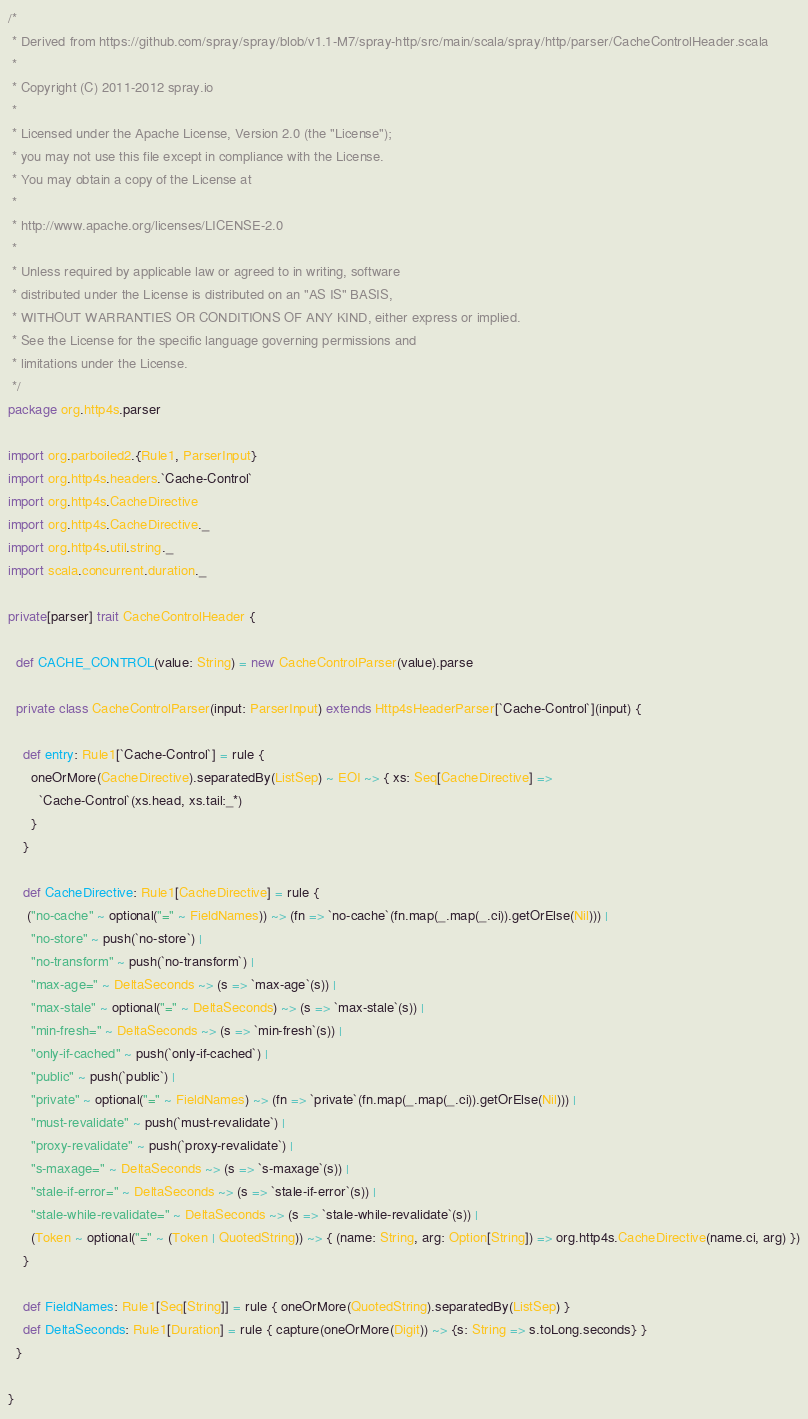<code> <loc_0><loc_0><loc_500><loc_500><_Scala_>/*
 * Derived from https://github.com/spray/spray/blob/v1.1-M7/spray-http/src/main/scala/spray/http/parser/CacheControlHeader.scala
 *
 * Copyright (C) 2011-2012 spray.io
 *
 * Licensed under the Apache License, Version 2.0 (the "License");
 * you may not use this file except in compliance with the License.
 * You may obtain a copy of the License at
 *
 * http://www.apache.org/licenses/LICENSE-2.0
 *
 * Unless required by applicable law or agreed to in writing, software
 * distributed under the License is distributed on an "AS IS" BASIS,
 * WITHOUT WARRANTIES OR CONDITIONS OF ANY KIND, either express or implied.
 * See the License for the specific language governing permissions and
 * limitations under the License.
 */
package org.http4s.parser

import org.parboiled2.{Rule1, ParserInput}
import org.http4s.headers.`Cache-Control`
import org.http4s.CacheDirective
import org.http4s.CacheDirective._
import org.http4s.util.string._
import scala.concurrent.duration._

private[parser] trait CacheControlHeader {

  def CACHE_CONTROL(value: String) = new CacheControlParser(value).parse

  private class CacheControlParser(input: ParserInput) extends Http4sHeaderParser[`Cache-Control`](input) {

    def entry: Rule1[`Cache-Control`] = rule {
      oneOrMore(CacheDirective).separatedBy(ListSep) ~ EOI ~> { xs: Seq[CacheDirective] =>
        `Cache-Control`(xs.head, xs.tail:_*)
      }
    }

    def CacheDirective: Rule1[CacheDirective] = rule {
     ("no-cache" ~ optional("=" ~ FieldNames)) ~> (fn => `no-cache`(fn.map(_.map(_.ci)).getOrElse(Nil))) |
      "no-store" ~ push(`no-store`) |
      "no-transform" ~ push(`no-transform`) |
      "max-age=" ~ DeltaSeconds ~> (s => `max-age`(s)) |
      "max-stale" ~ optional("=" ~ DeltaSeconds) ~> (s => `max-stale`(s)) |
      "min-fresh=" ~ DeltaSeconds ~> (s => `min-fresh`(s)) |
      "only-if-cached" ~ push(`only-if-cached`) |
      "public" ~ push(`public`) |
      "private" ~ optional("=" ~ FieldNames) ~> (fn => `private`(fn.map(_.map(_.ci)).getOrElse(Nil))) |
      "must-revalidate" ~ push(`must-revalidate`) |
      "proxy-revalidate" ~ push(`proxy-revalidate`) |
      "s-maxage=" ~ DeltaSeconds ~> (s => `s-maxage`(s)) |
      "stale-if-error=" ~ DeltaSeconds ~> (s => `stale-if-error`(s)) |
      "stale-while-revalidate=" ~ DeltaSeconds ~> (s => `stale-while-revalidate`(s)) |
      (Token ~ optional("=" ~ (Token | QuotedString)) ~> { (name: String, arg: Option[String]) => org.http4s.CacheDirective(name.ci, arg) })
    }

    def FieldNames: Rule1[Seq[String]] = rule { oneOrMore(QuotedString).separatedBy(ListSep) }
    def DeltaSeconds: Rule1[Duration] = rule { capture(oneOrMore(Digit)) ~> {s: String => s.toLong.seconds} }
  }

}
</code> 